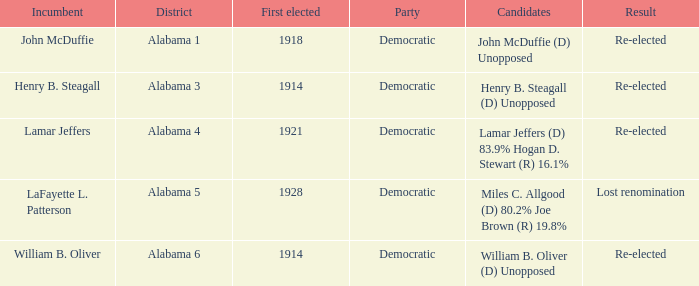How many in total were elected first in lost renomination? 1.0. 